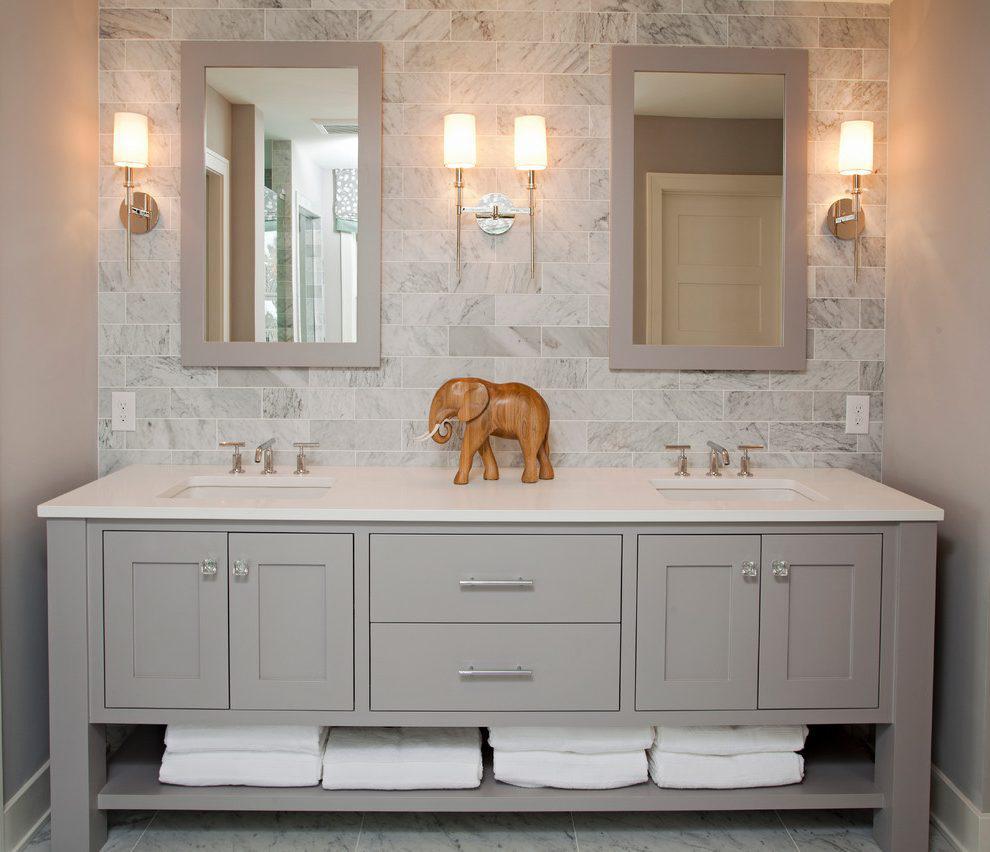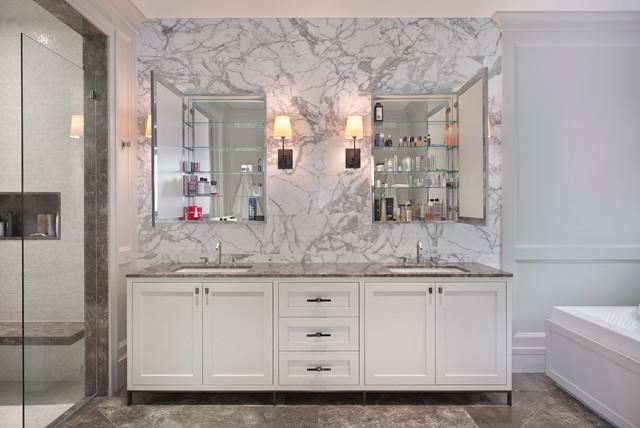The first image is the image on the left, the second image is the image on the right. For the images shown, is this caption "At least one image shows a pair of mirrors over a double vanity with the bottom of its cabinet open and holding towels." true? Answer yes or no. Yes. The first image is the image on the left, the second image is the image on the right. For the images shown, is this caption "One of the sink vanities does not have a double mirror above it." true? Answer yes or no. No. 